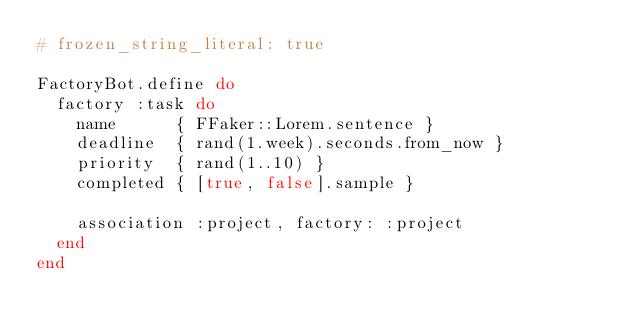Convert code to text. <code><loc_0><loc_0><loc_500><loc_500><_Ruby_># frozen_string_literal: true

FactoryBot.define do
  factory :task do
    name      { FFaker::Lorem.sentence }
    deadline  { rand(1.week).seconds.from_now }
    priority  { rand(1..10) }
    completed { [true, false].sample }

    association :project, factory: :project
  end
end
</code> 